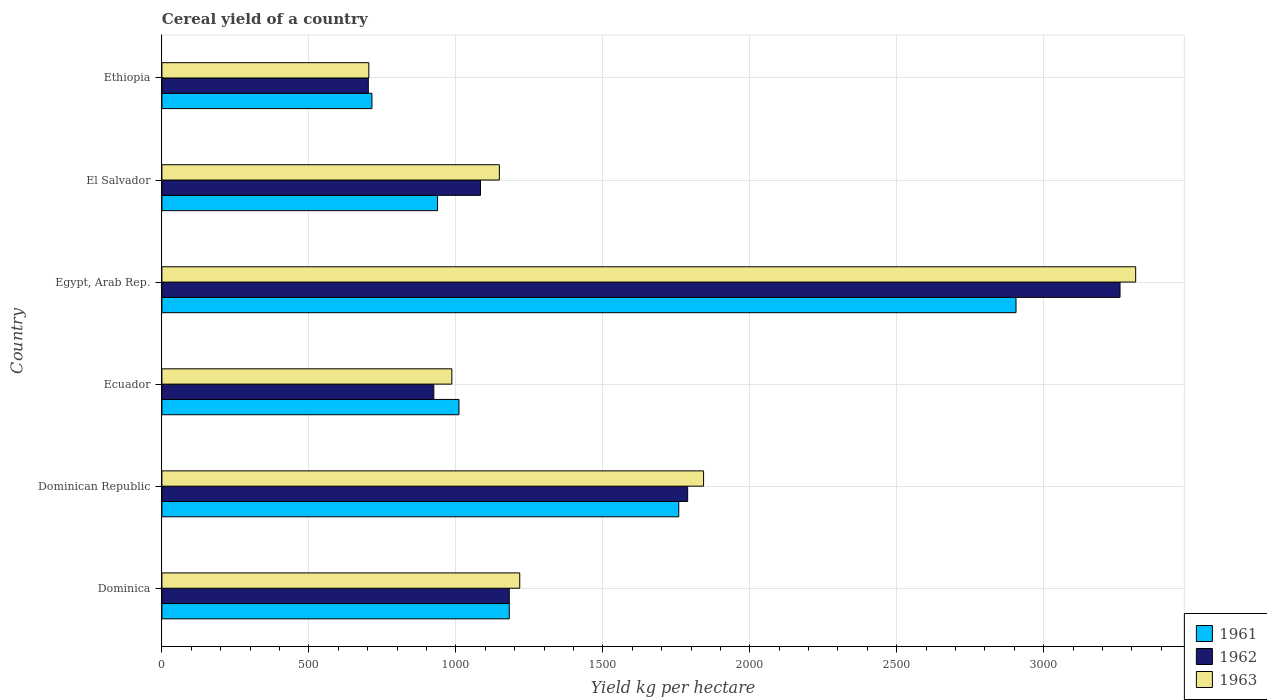How many groups of bars are there?
Give a very brief answer. 6. What is the label of the 4th group of bars from the top?
Ensure brevity in your answer.  Ecuador. In how many cases, is the number of bars for a given country not equal to the number of legend labels?
Give a very brief answer. 0. What is the total cereal yield in 1962 in Dominican Republic?
Keep it short and to the point. 1788.62. Across all countries, what is the maximum total cereal yield in 1961?
Make the answer very short. 2905.73. Across all countries, what is the minimum total cereal yield in 1961?
Offer a very short reply. 714.55. In which country was the total cereal yield in 1961 maximum?
Your answer should be compact. Egypt, Arab Rep. In which country was the total cereal yield in 1962 minimum?
Offer a very short reply. Ethiopia. What is the total total cereal yield in 1963 in the graph?
Your answer should be compact. 9211.48. What is the difference between the total cereal yield in 1961 in Ecuador and that in Egypt, Arab Rep.?
Your response must be concise. -1895.07. What is the difference between the total cereal yield in 1961 in El Salvador and the total cereal yield in 1963 in Ethiopia?
Offer a very short reply. 233.82. What is the average total cereal yield in 1962 per country?
Provide a succinct answer. 1490.2. What is the difference between the total cereal yield in 1962 and total cereal yield in 1961 in Egypt, Arab Rep.?
Your response must be concise. 353.83. In how many countries, is the total cereal yield in 1963 greater than 2600 kg per hectare?
Ensure brevity in your answer.  1. What is the ratio of the total cereal yield in 1961 in Ecuador to that in El Salvador?
Your response must be concise. 1.08. What is the difference between the highest and the second highest total cereal yield in 1961?
Keep it short and to the point. 1147.38. What is the difference between the highest and the lowest total cereal yield in 1962?
Provide a short and direct response. 2557.28. In how many countries, is the total cereal yield in 1961 greater than the average total cereal yield in 1961 taken over all countries?
Keep it short and to the point. 2. What does the 1st bar from the bottom in Dominica represents?
Provide a succinct answer. 1961. Is it the case that in every country, the sum of the total cereal yield in 1962 and total cereal yield in 1963 is greater than the total cereal yield in 1961?
Your answer should be compact. Yes. Are all the bars in the graph horizontal?
Ensure brevity in your answer.  Yes. How many countries are there in the graph?
Make the answer very short. 6. What is the difference between two consecutive major ticks on the X-axis?
Your response must be concise. 500. Are the values on the major ticks of X-axis written in scientific E-notation?
Offer a terse response. No. Does the graph contain any zero values?
Ensure brevity in your answer.  No. Does the graph contain grids?
Offer a very short reply. Yes. Where does the legend appear in the graph?
Offer a terse response. Bottom right. How are the legend labels stacked?
Your answer should be very brief. Vertical. What is the title of the graph?
Keep it short and to the point. Cereal yield of a country. What is the label or title of the X-axis?
Your answer should be very brief. Yield kg per hectare. What is the Yield kg per hectare of 1961 in Dominica?
Your answer should be compact. 1181.82. What is the Yield kg per hectare of 1962 in Dominica?
Your answer should be very brief. 1181.82. What is the Yield kg per hectare of 1963 in Dominica?
Ensure brevity in your answer.  1217.39. What is the Yield kg per hectare in 1961 in Dominican Republic?
Offer a very short reply. 1758.35. What is the Yield kg per hectare of 1962 in Dominican Republic?
Give a very brief answer. 1788.62. What is the Yield kg per hectare of 1963 in Dominican Republic?
Your response must be concise. 1842.8. What is the Yield kg per hectare of 1961 in Ecuador?
Provide a short and direct response. 1010.65. What is the Yield kg per hectare in 1962 in Ecuador?
Ensure brevity in your answer.  925.04. What is the Yield kg per hectare of 1963 in Ecuador?
Offer a terse response. 986.46. What is the Yield kg per hectare of 1961 in Egypt, Arab Rep.?
Give a very brief answer. 2905.73. What is the Yield kg per hectare of 1962 in Egypt, Arab Rep.?
Your answer should be compact. 3259.56. What is the Yield kg per hectare in 1963 in Egypt, Arab Rep.?
Keep it short and to the point. 3312.81. What is the Yield kg per hectare in 1961 in El Salvador?
Provide a short and direct response. 937.81. What is the Yield kg per hectare of 1962 in El Salvador?
Your response must be concise. 1083.88. What is the Yield kg per hectare of 1963 in El Salvador?
Keep it short and to the point. 1148.03. What is the Yield kg per hectare of 1961 in Ethiopia?
Your response must be concise. 714.55. What is the Yield kg per hectare of 1962 in Ethiopia?
Provide a short and direct response. 702.28. What is the Yield kg per hectare of 1963 in Ethiopia?
Make the answer very short. 703.99. Across all countries, what is the maximum Yield kg per hectare in 1961?
Offer a terse response. 2905.73. Across all countries, what is the maximum Yield kg per hectare of 1962?
Your answer should be very brief. 3259.56. Across all countries, what is the maximum Yield kg per hectare of 1963?
Your response must be concise. 3312.81. Across all countries, what is the minimum Yield kg per hectare of 1961?
Provide a succinct answer. 714.55. Across all countries, what is the minimum Yield kg per hectare in 1962?
Ensure brevity in your answer.  702.28. Across all countries, what is the minimum Yield kg per hectare in 1963?
Offer a terse response. 703.99. What is the total Yield kg per hectare in 1961 in the graph?
Give a very brief answer. 8508.91. What is the total Yield kg per hectare in 1962 in the graph?
Give a very brief answer. 8941.2. What is the total Yield kg per hectare of 1963 in the graph?
Give a very brief answer. 9211.48. What is the difference between the Yield kg per hectare in 1961 in Dominica and that in Dominican Republic?
Offer a very short reply. -576.53. What is the difference between the Yield kg per hectare of 1962 in Dominica and that in Dominican Republic?
Ensure brevity in your answer.  -606.8. What is the difference between the Yield kg per hectare of 1963 in Dominica and that in Dominican Republic?
Your response must be concise. -625.41. What is the difference between the Yield kg per hectare in 1961 in Dominica and that in Ecuador?
Offer a terse response. 171.16. What is the difference between the Yield kg per hectare of 1962 in Dominica and that in Ecuador?
Provide a succinct answer. 256.77. What is the difference between the Yield kg per hectare in 1963 in Dominica and that in Ecuador?
Make the answer very short. 230.93. What is the difference between the Yield kg per hectare of 1961 in Dominica and that in Egypt, Arab Rep.?
Offer a very short reply. -1723.91. What is the difference between the Yield kg per hectare of 1962 in Dominica and that in Egypt, Arab Rep.?
Your answer should be very brief. -2077.74. What is the difference between the Yield kg per hectare in 1963 in Dominica and that in Egypt, Arab Rep.?
Offer a terse response. -2095.42. What is the difference between the Yield kg per hectare in 1961 in Dominica and that in El Salvador?
Ensure brevity in your answer.  244.01. What is the difference between the Yield kg per hectare in 1962 in Dominica and that in El Salvador?
Your response must be concise. 97.94. What is the difference between the Yield kg per hectare in 1963 in Dominica and that in El Salvador?
Your answer should be very brief. 69.36. What is the difference between the Yield kg per hectare in 1961 in Dominica and that in Ethiopia?
Provide a succinct answer. 467.26. What is the difference between the Yield kg per hectare of 1962 in Dominica and that in Ethiopia?
Your response must be concise. 479.54. What is the difference between the Yield kg per hectare of 1963 in Dominica and that in Ethiopia?
Your answer should be very brief. 513.4. What is the difference between the Yield kg per hectare in 1961 in Dominican Republic and that in Ecuador?
Offer a terse response. 747.69. What is the difference between the Yield kg per hectare in 1962 in Dominican Republic and that in Ecuador?
Your answer should be very brief. 863.57. What is the difference between the Yield kg per hectare of 1963 in Dominican Republic and that in Ecuador?
Ensure brevity in your answer.  856.34. What is the difference between the Yield kg per hectare of 1961 in Dominican Republic and that in Egypt, Arab Rep.?
Your answer should be very brief. -1147.38. What is the difference between the Yield kg per hectare of 1962 in Dominican Republic and that in Egypt, Arab Rep.?
Keep it short and to the point. -1470.94. What is the difference between the Yield kg per hectare in 1963 in Dominican Republic and that in Egypt, Arab Rep.?
Your answer should be very brief. -1470.01. What is the difference between the Yield kg per hectare of 1961 in Dominican Republic and that in El Salvador?
Your answer should be compact. 820.54. What is the difference between the Yield kg per hectare in 1962 in Dominican Republic and that in El Salvador?
Make the answer very short. 704.73. What is the difference between the Yield kg per hectare in 1963 in Dominican Republic and that in El Salvador?
Ensure brevity in your answer.  694.77. What is the difference between the Yield kg per hectare of 1961 in Dominican Republic and that in Ethiopia?
Give a very brief answer. 1043.8. What is the difference between the Yield kg per hectare of 1962 in Dominican Republic and that in Ethiopia?
Your answer should be compact. 1086.33. What is the difference between the Yield kg per hectare in 1963 in Dominican Republic and that in Ethiopia?
Offer a very short reply. 1138.81. What is the difference between the Yield kg per hectare of 1961 in Ecuador and that in Egypt, Arab Rep.?
Make the answer very short. -1895.07. What is the difference between the Yield kg per hectare in 1962 in Ecuador and that in Egypt, Arab Rep.?
Give a very brief answer. -2334.51. What is the difference between the Yield kg per hectare in 1963 in Ecuador and that in Egypt, Arab Rep.?
Provide a short and direct response. -2326.35. What is the difference between the Yield kg per hectare of 1961 in Ecuador and that in El Salvador?
Your answer should be very brief. 72.84. What is the difference between the Yield kg per hectare in 1962 in Ecuador and that in El Salvador?
Offer a terse response. -158.84. What is the difference between the Yield kg per hectare of 1963 in Ecuador and that in El Salvador?
Offer a terse response. -161.57. What is the difference between the Yield kg per hectare of 1961 in Ecuador and that in Ethiopia?
Your response must be concise. 296.1. What is the difference between the Yield kg per hectare of 1962 in Ecuador and that in Ethiopia?
Provide a short and direct response. 222.76. What is the difference between the Yield kg per hectare of 1963 in Ecuador and that in Ethiopia?
Offer a terse response. 282.47. What is the difference between the Yield kg per hectare of 1961 in Egypt, Arab Rep. and that in El Salvador?
Give a very brief answer. 1967.92. What is the difference between the Yield kg per hectare of 1962 in Egypt, Arab Rep. and that in El Salvador?
Your answer should be very brief. 2175.68. What is the difference between the Yield kg per hectare in 1963 in Egypt, Arab Rep. and that in El Salvador?
Give a very brief answer. 2164.78. What is the difference between the Yield kg per hectare of 1961 in Egypt, Arab Rep. and that in Ethiopia?
Give a very brief answer. 2191.18. What is the difference between the Yield kg per hectare of 1962 in Egypt, Arab Rep. and that in Ethiopia?
Provide a succinct answer. 2557.28. What is the difference between the Yield kg per hectare of 1963 in Egypt, Arab Rep. and that in Ethiopia?
Provide a succinct answer. 2608.82. What is the difference between the Yield kg per hectare in 1961 in El Salvador and that in Ethiopia?
Give a very brief answer. 223.26. What is the difference between the Yield kg per hectare in 1962 in El Salvador and that in Ethiopia?
Provide a succinct answer. 381.6. What is the difference between the Yield kg per hectare in 1963 in El Salvador and that in Ethiopia?
Your answer should be compact. 444.04. What is the difference between the Yield kg per hectare of 1961 in Dominica and the Yield kg per hectare of 1962 in Dominican Republic?
Provide a succinct answer. -606.8. What is the difference between the Yield kg per hectare in 1961 in Dominica and the Yield kg per hectare in 1963 in Dominican Republic?
Your answer should be very brief. -660.98. What is the difference between the Yield kg per hectare of 1962 in Dominica and the Yield kg per hectare of 1963 in Dominican Republic?
Your answer should be very brief. -660.98. What is the difference between the Yield kg per hectare in 1961 in Dominica and the Yield kg per hectare in 1962 in Ecuador?
Offer a very short reply. 256.77. What is the difference between the Yield kg per hectare of 1961 in Dominica and the Yield kg per hectare of 1963 in Ecuador?
Keep it short and to the point. 195.36. What is the difference between the Yield kg per hectare of 1962 in Dominica and the Yield kg per hectare of 1963 in Ecuador?
Keep it short and to the point. 195.36. What is the difference between the Yield kg per hectare of 1961 in Dominica and the Yield kg per hectare of 1962 in Egypt, Arab Rep.?
Offer a very short reply. -2077.74. What is the difference between the Yield kg per hectare of 1961 in Dominica and the Yield kg per hectare of 1963 in Egypt, Arab Rep.?
Provide a short and direct response. -2130.99. What is the difference between the Yield kg per hectare of 1962 in Dominica and the Yield kg per hectare of 1963 in Egypt, Arab Rep.?
Give a very brief answer. -2130.99. What is the difference between the Yield kg per hectare of 1961 in Dominica and the Yield kg per hectare of 1962 in El Salvador?
Offer a very short reply. 97.94. What is the difference between the Yield kg per hectare of 1961 in Dominica and the Yield kg per hectare of 1963 in El Salvador?
Your answer should be compact. 33.79. What is the difference between the Yield kg per hectare in 1962 in Dominica and the Yield kg per hectare in 1963 in El Salvador?
Offer a very short reply. 33.79. What is the difference between the Yield kg per hectare in 1961 in Dominica and the Yield kg per hectare in 1962 in Ethiopia?
Offer a very short reply. 479.54. What is the difference between the Yield kg per hectare in 1961 in Dominica and the Yield kg per hectare in 1963 in Ethiopia?
Offer a very short reply. 477.82. What is the difference between the Yield kg per hectare in 1962 in Dominica and the Yield kg per hectare in 1963 in Ethiopia?
Ensure brevity in your answer.  477.82. What is the difference between the Yield kg per hectare of 1961 in Dominican Republic and the Yield kg per hectare of 1962 in Ecuador?
Provide a succinct answer. 833.3. What is the difference between the Yield kg per hectare of 1961 in Dominican Republic and the Yield kg per hectare of 1963 in Ecuador?
Ensure brevity in your answer.  771.89. What is the difference between the Yield kg per hectare of 1962 in Dominican Republic and the Yield kg per hectare of 1963 in Ecuador?
Your answer should be compact. 802.16. What is the difference between the Yield kg per hectare of 1961 in Dominican Republic and the Yield kg per hectare of 1962 in Egypt, Arab Rep.?
Your answer should be compact. -1501.21. What is the difference between the Yield kg per hectare in 1961 in Dominican Republic and the Yield kg per hectare in 1963 in Egypt, Arab Rep.?
Provide a succinct answer. -1554.46. What is the difference between the Yield kg per hectare in 1962 in Dominican Republic and the Yield kg per hectare in 1963 in Egypt, Arab Rep.?
Your answer should be very brief. -1524.19. What is the difference between the Yield kg per hectare of 1961 in Dominican Republic and the Yield kg per hectare of 1962 in El Salvador?
Offer a terse response. 674.47. What is the difference between the Yield kg per hectare of 1961 in Dominican Republic and the Yield kg per hectare of 1963 in El Salvador?
Provide a short and direct response. 610.32. What is the difference between the Yield kg per hectare in 1962 in Dominican Republic and the Yield kg per hectare in 1963 in El Salvador?
Your answer should be compact. 640.59. What is the difference between the Yield kg per hectare of 1961 in Dominican Republic and the Yield kg per hectare of 1962 in Ethiopia?
Ensure brevity in your answer.  1056.07. What is the difference between the Yield kg per hectare of 1961 in Dominican Republic and the Yield kg per hectare of 1963 in Ethiopia?
Offer a terse response. 1054.36. What is the difference between the Yield kg per hectare of 1962 in Dominican Republic and the Yield kg per hectare of 1963 in Ethiopia?
Provide a short and direct response. 1084.62. What is the difference between the Yield kg per hectare of 1961 in Ecuador and the Yield kg per hectare of 1962 in Egypt, Arab Rep.?
Make the answer very short. -2248.9. What is the difference between the Yield kg per hectare in 1961 in Ecuador and the Yield kg per hectare in 1963 in Egypt, Arab Rep.?
Offer a terse response. -2302.15. What is the difference between the Yield kg per hectare of 1962 in Ecuador and the Yield kg per hectare of 1963 in Egypt, Arab Rep.?
Offer a terse response. -2387.76. What is the difference between the Yield kg per hectare of 1961 in Ecuador and the Yield kg per hectare of 1962 in El Salvador?
Provide a short and direct response. -73.23. What is the difference between the Yield kg per hectare in 1961 in Ecuador and the Yield kg per hectare in 1963 in El Salvador?
Your answer should be compact. -137.37. What is the difference between the Yield kg per hectare of 1962 in Ecuador and the Yield kg per hectare of 1963 in El Salvador?
Provide a succinct answer. -222.98. What is the difference between the Yield kg per hectare in 1961 in Ecuador and the Yield kg per hectare in 1962 in Ethiopia?
Your answer should be very brief. 308.37. What is the difference between the Yield kg per hectare of 1961 in Ecuador and the Yield kg per hectare of 1963 in Ethiopia?
Your response must be concise. 306.66. What is the difference between the Yield kg per hectare in 1962 in Ecuador and the Yield kg per hectare in 1963 in Ethiopia?
Offer a terse response. 221.05. What is the difference between the Yield kg per hectare in 1961 in Egypt, Arab Rep. and the Yield kg per hectare in 1962 in El Salvador?
Provide a short and direct response. 1821.85. What is the difference between the Yield kg per hectare in 1961 in Egypt, Arab Rep. and the Yield kg per hectare in 1963 in El Salvador?
Give a very brief answer. 1757.7. What is the difference between the Yield kg per hectare of 1962 in Egypt, Arab Rep. and the Yield kg per hectare of 1963 in El Salvador?
Ensure brevity in your answer.  2111.53. What is the difference between the Yield kg per hectare of 1961 in Egypt, Arab Rep. and the Yield kg per hectare of 1962 in Ethiopia?
Your response must be concise. 2203.45. What is the difference between the Yield kg per hectare in 1961 in Egypt, Arab Rep. and the Yield kg per hectare in 1963 in Ethiopia?
Make the answer very short. 2201.74. What is the difference between the Yield kg per hectare in 1962 in Egypt, Arab Rep. and the Yield kg per hectare in 1963 in Ethiopia?
Your answer should be very brief. 2555.56. What is the difference between the Yield kg per hectare in 1961 in El Salvador and the Yield kg per hectare in 1962 in Ethiopia?
Offer a very short reply. 235.53. What is the difference between the Yield kg per hectare of 1961 in El Salvador and the Yield kg per hectare of 1963 in Ethiopia?
Your response must be concise. 233.82. What is the difference between the Yield kg per hectare of 1962 in El Salvador and the Yield kg per hectare of 1963 in Ethiopia?
Keep it short and to the point. 379.89. What is the average Yield kg per hectare in 1961 per country?
Make the answer very short. 1418.15. What is the average Yield kg per hectare in 1962 per country?
Your response must be concise. 1490.2. What is the average Yield kg per hectare in 1963 per country?
Provide a short and direct response. 1535.25. What is the difference between the Yield kg per hectare in 1961 and Yield kg per hectare in 1962 in Dominica?
Provide a short and direct response. 0. What is the difference between the Yield kg per hectare in 1961 and Yield kg per hectare in 1963 in Dominica?
Provide a short and direct response. -35.57. What is the difference between the Yield kg per hectare of 1962 and Yield kg per hectare of 1963 in Dominica?
Offer a terse response. -35.57. What is the difference between the Yield kg per hectare of 1961 and Yield kg per hectare of 1962 in Dominican Republic?
Make the answer very short. -30.27. What is the difference between the Yield kg per hectare in 1961 and Yield kg per hectare in 1963 in Dominican Republic?
Offer a terse response. -84.45. What is the difference between the Yield kg per hectare of 1962 and Yield kg per hectare of 1963 in Dominican Republic?
Provide a succinct answer. -54.19. What is the difference between the Yield kg per hectare in 1961 and Yield kg per hectare in 1962 in Ecuador?
Give a very brief answer. 85.61. What is the difference between the Yield kg per hectare of 1961 and Yield kg per hectare of 1963 in Ecuador?
Your answer should be compact. 24.2. What is the difference between the Yield kg per hectare of 1962 and Yield kg per hectare of 1963 in Ecuador?
Ensure brevity in your answer.  -61.41. What is the difference between the Yield kg per hectare in 1961 and Yield kg per hectare in 1962 in Egypt, Arab Rep.?
Your answer should be very brief. -353.83. What is the difference between the Yield kg per hectare in 1961 and Yield kg per hectare in 1963 in Egypt, Arab Rep.?
Provide a short and direct response. -407.08. What is the difference between the Yield kg per hectare in 1962 and Yield kg per hectare in 1963 in Egypt, Arab Rep.?
Offer a terse response. -53.25. What is the difference between the Yield kg per hectare in 1961 and Yield kg per hectare in 1962 in El Salvador?
Keep it short and to the point. -146.07. What is the difference between the Yield kg per hectare in 1961 and Yield kg per hectare in 1963 in El Salvador?
Offer a terse response. -210.22. What is the difference between the Yield kg per hectare of 1962 and Yield kg per hectare of 1963 in El Salvador?
Give a very brief answer. -64.15. What is the difference between the Yield kg per hectare of 1961 and Yield kg per hectare of 1962 in Ethiopia?
Offer a terse response. 12.27. What is the difference between the Yield kg per hectare in 1961 and Yield kg per hectare in 1963 in Ethiopia?
Your answer should be compact. 10.56. What is the difference between the Yield kg per hectare in 1962 and Yield kg per hectare in 1963 in Ethiopia?
Your answer should be very brief. -1.71. What is the ratio of the Yield kg per hectare of 1961 in Dominica to that in Dominican Republic?
Give a very brief answer. 0.67. What is the ratio of the Yield kg per hectare in 1962 in Dominica to that in Dominican Republic?
Offer a very short reply. 0.66. What is the ratio of the Yield kg per hectare of 1963 in Dominica to that in Dominican Republic?
Your answer should be very brief. 0.66. What is the ratio of the Yield kg per hectare of 1961 in Dominica to that in Ecuador?
Your response must be concise. 1.17. What is the ratio of the Yield kg per hectare in 1962 in Dominica to that in Ecuador?
Offer a terse response. 1.28. What is the ratio of the Yield kg per hectare in 1963 in Dominica to that in Ecuador?
Give a very brief answer. 1.23. What is the ratio of the Yield kg per hectare in 1961 in Dominica to that in Egypt, Arab Rep.?
Your response must be concise. 0.41. What is the ratio of the Yield kg per hectare of 1962 in Dominica to that in Egypt, Arab Rep.?
Offer a terse response. 0.36. What is the ratio of the Yield kg per hectare of 1963 in Dominica to that in Egypt, Arab Rep.?
Your answer should be compact. 0.37. What is the ratio of the Yield kg per hectare in 1961 in Dominica to that in El Salvador?
Offer a very short reply. 1.26. What is the ratio of the Yield kg per hectare of 1962 in Dominica to that in El Salvador?
Provide a succinct answer. 1.09. What is the ratio of the Yield kg per hectare of 1963 in Dominica to that in El Salvador?
Give a very brief answer. 1.06. What is the ratio of the Yield kg per hectare of 1961 in Dominica to that in Ethiopia?
Offer a terse response. 1.65. What is the ratio of the Yield kg per hectare in 1962 in Dominica to that in Ethiopia?
Ensure brevity in your answer.  1.68. What is the ratio of the Yield kg per hectare of 1963 in Dominica to that in Ethiopia?
Provide a short and direct response. 1.73. What is the ratio of the Yield kg per hectare in 1961 in Dominican Republic to that in Ecuador?
Your answer should be very brief. 1.74. What is the ratio of the Yield kg per hectare of 1962 in Dominican Republic to that in Ecuador?
Keep it short and to the point. 1.93. What is the ratio of the Yield kg per hectare in 1963 in Dominican Republic to that in Ecuador?
Your response must be concise. 1.87. What is the ratio of the Yield kg per hectare in 1961 in Dominican Republic to that in Egypt, Arab Rep.?
Offer a very short reply. 0.61. What is the ratio of the Yield kg per hectare in 1962 in Dominican Republic to that in Egypt, Arab Rep.?
Offer a terse response. 0.55. What is the ratio of the Yield kg per hectare of 1963 in Dominican Republic to that in Egypt, Arab Rep.?
Provide a short and direct response. 0.56. What is the ratio of the Yield kg per hectare of 1961 in Dominican Republic to that in El Salvador?
Make the answer very short. 1.88. What is the ratio of the Yield kg per hectare of 1962 in Dominican Republic to that in El Salvador?
Offer a very short reply. 1.65. What is the ratio of the Yield kg per hectare in 1963 in Dominican Republic to that in El Salvador?
Give a very brief answer. 1.61. What is the ratio of the Yield kg per hectare in 1961 in Dominican Republic to that in Ethiopia?
Your response must be concise. 2.46. What is the ratio of the Yield kg per hectare in 1962 in Dominican Republic to that in Ethiopia?
Provide a short and direct response. 2.55. What is the ratio of the Yield kg per hectare in 1963 in Dominican Republic to that in Ethiopia?
Make the answer very short. 2.62. What is the ratio of the Yield kg per hectare in 1961 in Ecuador to that in Egypt, Arab Rep.?
Your answer should be compact. 0.35. What is the ratio of the Yield kg per hectare of 1962 in Ecuador to that in Egypt, Arab Rep.?
Provide a succinct answer. 0.28. What is the ratio of the Yield kg per hectare of 1963 in Ecuador to that in Egypt, Arab Rep.?
Provide a short and direct response. 0.3. What is the ratio of the Yield kg per hectare in 1961 in Ecuador to that in El Salvador?
Your response must be concise. 1.08. What is the ratio of the Yield kg per hectare of 1962 in Ecuador to that in El Salvador?
Your response must be concise. 0.85. What is the ratio of the Yield kg per hectare of 1963 in Ecuador to that in El Salvador?
Provide a short and direct response. 0.86. What is the ratio of the Yield kg per hectare in 1961 in Ecuador to that in Ethiopia?
Provide a succinct answer. 1.41. What is the ratio of the Yield kg per hectare of 1962 in Ecuador to that in Ethiopia?
Your answer should be compact. 1.32. What is the ratio of the Yield kg per hectare of 1963 in Ecuador to that in Ethiopia?
Keep it short and to the point. 1.4. What is the ratio of the Yield kg per hectare in 1961 in Egypt, Arab Rep. to that in El Salvador?
Provide a short and direct response. 3.1. What is the ratio of the Yield kg per hectare in 1962 in Egypt, Arab Rep. to that in El Salvador?
Keep it short and to the point. 3.01. What is the ratio of the Yield kg per hectare of 1963 in Egypt, Arab Rep. to that in El Salvador?
Ensure brevity in your answer.  2.89. What is the ratio of the Yield kg per hectare of 1961 in Egypt, Arab Rep. to that in Ethiopia?
Your answer should be compact. 4.07. What is the ratio of the Yield kg per hectare of 1962 in Egypt, Arab Rep. to that in Ethiopia?
Provide a succinct answer. 4.64. What is the ratio of the Yield kg per hectare in 1963 in Egypt, Arab Rep. to that in Ethiopia?
Provide a succinct answer. 4.71. What is the ratio of the Yield kg per hectare in 1961 in El Salvador to that in Ethiopia?
Your answer should be compact. 1.31. What is the ratio of the Yield kg per hectare in 1962 in El Salvador to that in Ethiopia?
Offer a terse response. 1.54. What is the ratio of the Yield kg per hectare in 1963 in El Salvador to that in Ethiopia?
Give a very brief answer. 1.63. What is the difference between the highest and the second highest Yield kg per hectare in 1961?
Make the answer very short. 1147.38. What is the difference between the highest and the second highest Yield kg per hectare of 1962?
Provide a succinct answer. 1470.94. What is the difference between the highest and the second highest Yield kg per hectare in 1963?
Provide a short and direct response. 1470.01. What is the difference between the highest and the lowest Yield kg per hectare of 1961?
Give a very brief answer. 2191.18. What is the difference between the highest and the lowest Yield kg per hectare of 1962?
Your answer should be very brief. 2557.28. What is the difference between the highest and the lowest Yield kg per hectare in 1963?
Your response must be concise. 2608.82. 